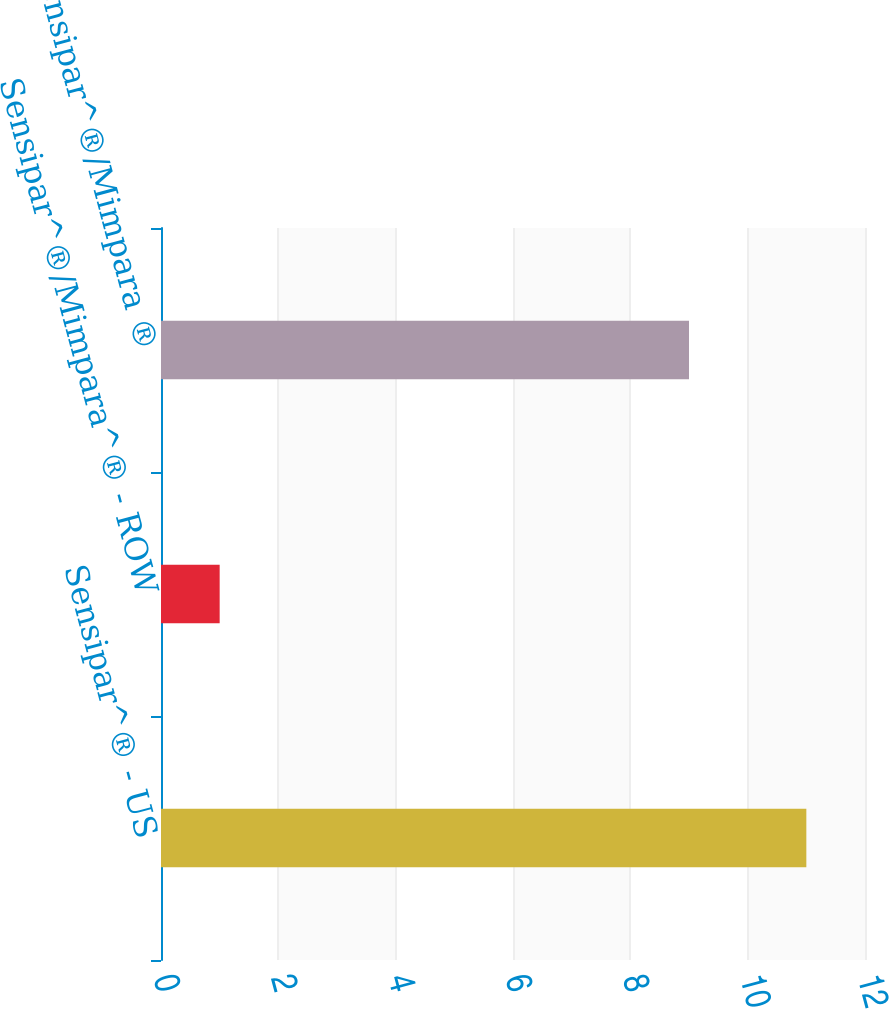Convert chart. <chart><loc_0><loc_0><loc_500><loc_500><bar_chart><fcel>Sensipar^® - US<fcel>Sensipar^®/Mimpara^® - ROW<fcel>Total Sensipar^®/Mimpara ®<nl><fcel>11<fcel>1<fcel>9<nl></chart> 